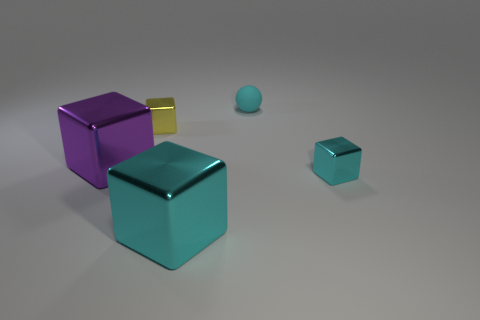Subtract all purple cubes. How many cubes are left? 3 Subtract all yellow cylinders. How many cyan cubes are left? 2 Subtract all yellow blocks. How many blocks are left? 3 Subtract all balls. How many objects are left? 4 Add 1 big cubes. How many objects exist? 6 Subtract 3 blocks. How many blocks are left? 1 Subtract all gray balls. Subtract all large cyan blocks. How many objects are left? 4 Add 2 tiny matte objects. How many tiny matte objects are left? 3 Add 2 small matte things. How many small matte things exist? 3 Subtract 0 blue blocks. How many objects are left? 5 